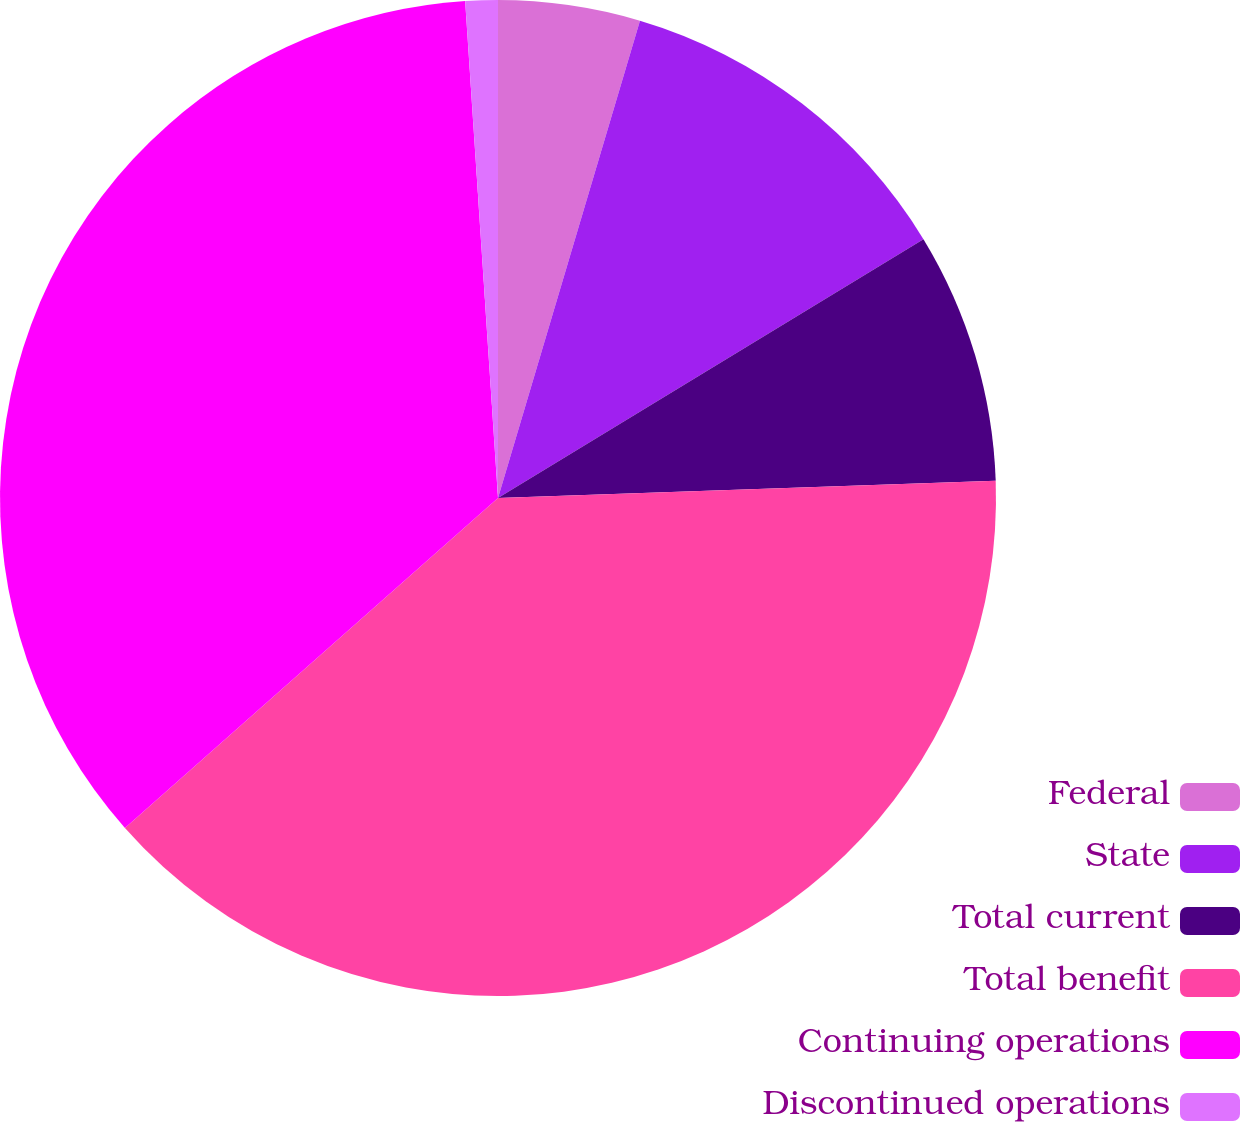Convert chart. <chart><loc_0><loc_0><loc_500><loc_500><pie_chart><fcel>Federal<fcel>State<fcel>Total current<fcel>Total benefit<fcel>Continuing operations<fcel>Discontinued operations<nl><fcel>4.6%<fcel>11.7%<fcel>8.15%<fcel>39.02%<fcel>35.47%<fcel>1.05%<nl></chart> 